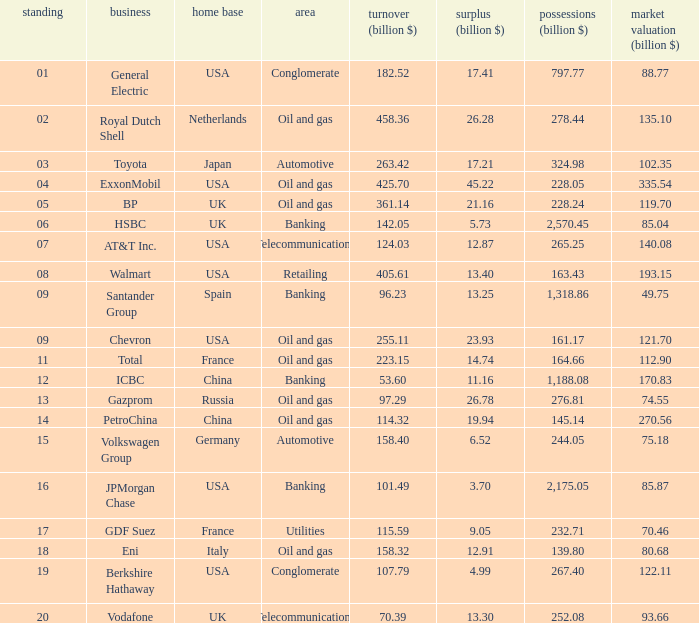Name the lowest Market Value (billion $) which has Assets (billion $) larger than 276.81, and a Company of toyota, and Profits (billion $) larger than 17.21? None. 